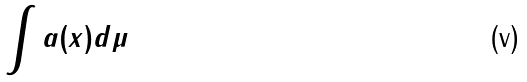<formula> <loc_0><loc_0><loc_500><loc_500>\int a ( x ) d \mu</formula> 